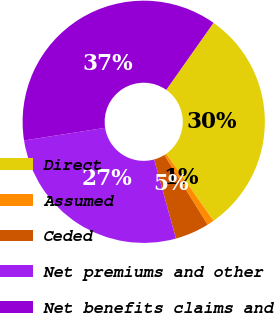<chart> <loc_0><loc_0><loc_500><loc_500><pie_chart><fcel>Direct<fcel>Assumed<fcel>Ceded<fcel>Net premiums and other<fcel>Net benefits claims and<nl><fcel>30.45%<fcel>0.93%<fcel>4.56%<fcel>26.82%<fcel>37.24%<nl></chart> 